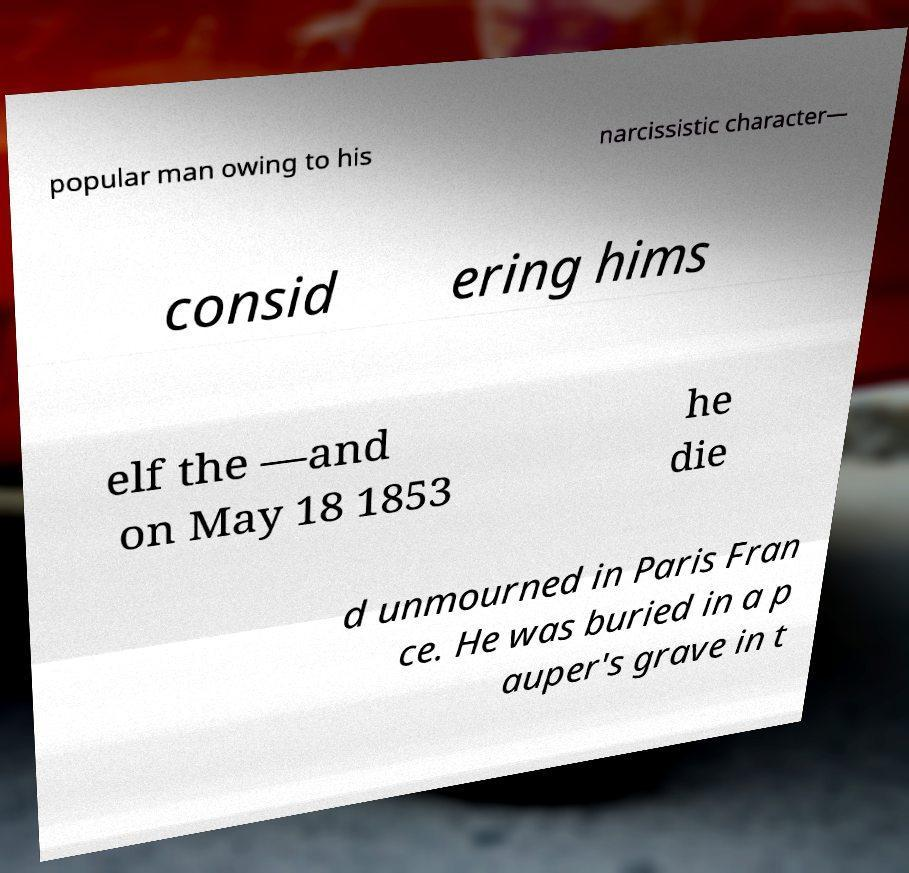What messages or text are displayed in this image? I need them in a readable, typed format. popular man owing to his narcissistic character— consid ering hims elf the —and on May 18 1853 he die d unmourned in Paris Fran ce. He was buried in a p auper's grave in t 